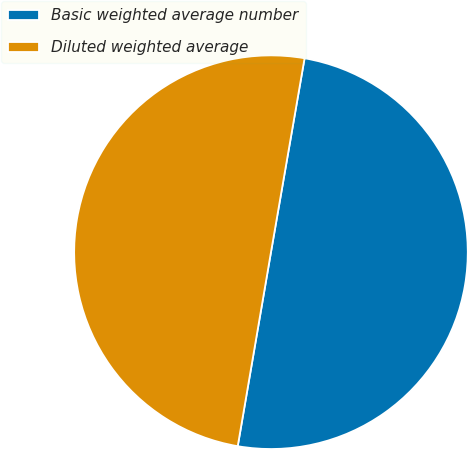Convert chart to OTSL. <chart><loc_0><loc_0><loc_500><loc_500><pie_chart><fcel>Basic weighted average number<fcel>Diluted weighted average<nl><fcel>49.97%<fcel>50.03%<nl></chart> 